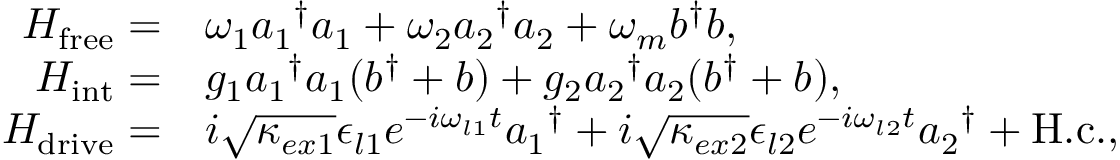<formula> <loc_0><loc_0><loc_500><loc_500>\begin{array} { r l } { H _ { f r e e } = } & { \omega _ { 1 } { a _ { 1 } } ^ { \dagger } a _ { 1 } + \omega _ { 2 } { a _ { 2 } } ^ { \dagger } a _ { 2 } + \omega _ { m } b ^ { \dagger } b , } \\ { H _ { i n t } = } & { g _ { 1 } { a _ { 1 } } ^ { \dagger } a _ { 1 } ( b ^ { \dagger } + b ) + g _ { 2 } { a _ { 2 } } ^ { \dagger } a _ { 2 } ( b ^ { \dagger } + b ) , } \\ { H _ { d r i v e } = } & { i \sqrt { \kappa _ { e x 1 } } \epsilon _ { l 1 } e ^ { - i \omega _ { l 1 } t } { a _ { 1 } } ^ { \dagger } + i \sqrt { \kappa _ { e x 2 } } \epsilon _ { l 2 } e ^ { - i \omega _ { l 2 } t } { a _ { 2 } } ^ { \dagger } + H . c . , } \end{array}</formula> 